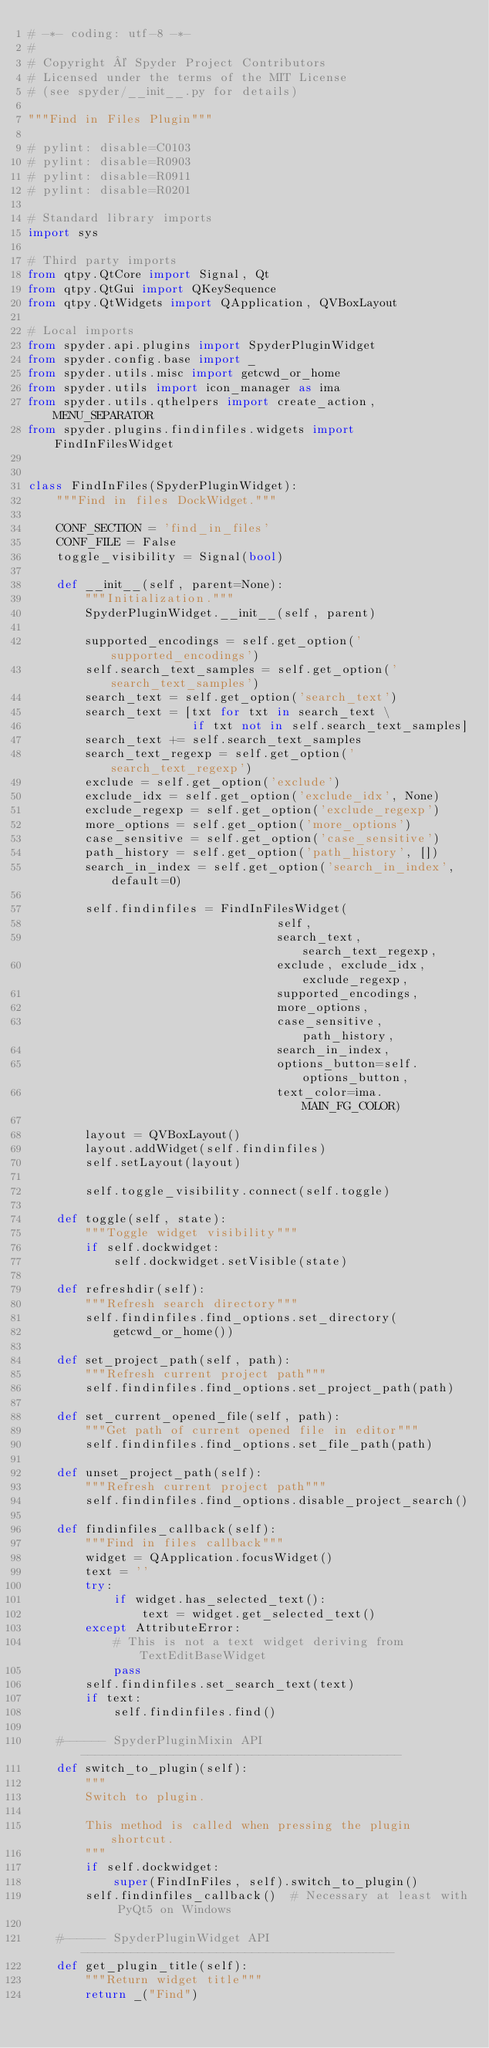<code> <loc_0><loc_0><loc_500><loc_500><_Python_># -*- coding: utf-8 -*-
#
# Copyright © Spyder Project Contributors
# Licensed under the terms of the MIT License
# (see spyder/__init__.py for details)

"""Find in Files Plugin"""

# pylint: disable=C0103
# pylint: disable=R0903
# pylint: disable=R0911
# pylint: disable=R0201

# Standard library imports
import sys

# Third party imports
from qtpy.QtCore import Signal, Qt
from qtpy.QtGui import QKeySequence
from qtpy.QtWidgets import QApplication, QVBoxLayout

# Local imports
from spyder.api.plugins import SpyderPluginWidget
from spyder.config.base import _
from spyder.utils.misc import getcwd_or_home
from spyder.utils import icon_manager as ima
from spyder.utils.qthelpers import create_action, MENU_SEPARATOR
from spyder.plugins.findinfiles.widgets import FindInFilesWidget


class FindInFiles(SpyderPluginWidget):
    """Find in files DockWidget."""

    CONF_SECTION = 'find_in_files'
    CONF_FILE = False
    toggle_visibility = Signal(bool)

    def __init__(self, parent=None):
        """Initialization."""
        SpyderPluginWidget.__init__(self, parent)

        supported_encodings = self.get_option('supported_encodings')
        self.search_text_samples = self.get_option('search_text_samples')
        search_text = self.get_option('search_text')
        search_text = [txt for txt in search_text \
                       if txt not in self.search_text_samples]
        search_text += self.search_text_samples
        search_text_regexp = self.get_option('search_text_regexp')
        exclude = self.get_option('exclude')
        exclude_idx = self.get_option('exclude_idx', None)
        exclude_regexp = self.get_option('exclude_regexp')
        more_options = self.get_option('more_options')
        case_sensitive = self.get_option('case_sensitive')
        path_history = self.get_option('path_history', [])
        search_in_index = self.get_option('search_in_index', default=0)

        self.findinfiles = FindInFilesWidget(
                                   self,
                                   search_text, search_text_regexp,
                                   exclude, exclude_idx, exclude_regexp,
                                   supported_encodings,
                                   more_options,
                                   case_sensitive, path_history,
                                   search_in_index,
                                   options_button=self.options_button,
                                   text_color=ima.MAIN_FG_COLOR)

        layout = QVBoxLayout()
        layout.addWidget(self.findinfiles)
        self.setLayout(layout)

        self.toggle_visibility.connect(self.toggle)
        
    def toggle(self, state):
        """Toggle widget visibility"""
        if self.dockwidget:
            self.dockwidget.setVisible(state)
    
    def refreshdir(self):
        """Refresh search directory"""
        self.findinfiles.find_options.set_directory(
            getcwd_or_home())

    def set_project_path(self, path):
        """Refresh current project path"""
        self.findinfiles.find_options.set_project_path(path)

    def set_current_opened_file(self, path):
        """Get path of current opened file in editor"""
        self.findinfiles.find_options.set_file_path(path)

    def unset_project_path(self):
        """Refresh current project path"""
        self.findinfiles.find_options.disable_project_search()

    def findinfiles_callback(self):
        """Find in files callback"""
        widget = QApplication.focusWidget()
        text = ''
        try:
            if widget.has_selected_text():
                text = widget.get_selected_text()
        except AttributeError:
            # This is not a text widget deriving from TextEditBaseWidget
            pass
        self.findinfiles.set_search_text(text)
        if text:
            self.findinfiles.find()

    #------ SpyderPluginMixin API ---------------------------------------------
    def switch_to_plugin(self):
        """
        Switch to plugin.

        This method is called when pressing the plugin shortcut.
        """
        if self.dockwidget:
            super(FindInFiles, self).switch_to_plugin()
        self.findinfiles_callback()  # Necessary at least with PyQt5 on Windows

    #------ SpyderPluginWidget API --------------------------------------------
    def get_plugin_title(self):
        """Return widget title"""
        return _("Find")
    </code> 